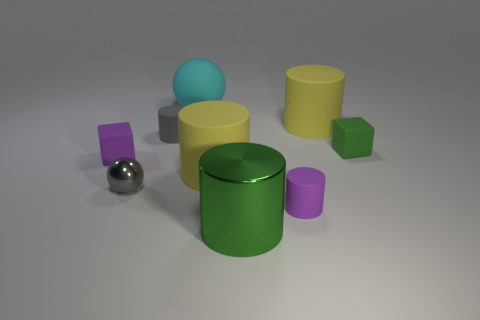Subtract all small purple cylinders. How many cylinders are left? 4 Subtract 2 cylinders. How many cylinders are left? 3 Add 1 tiny purple objects. How many objects exist? 10 Subtract all cubes. How many objects are left? 7 Add 7 gray cylinders. How many gray cylinders exist? 8 Subtract all purple cylinders. How many cylinders are left? 4 Subtract 0 cyan cubes. How many objects are left? 9 Subtract all brown cylinders. Subtract all yellow cubes. How many cylinders are left? 5 Subtract all green spheres. How many purple cylinders are left? 1 Subtract all big objects. Subtract all big green things. How many objects are left? 4 